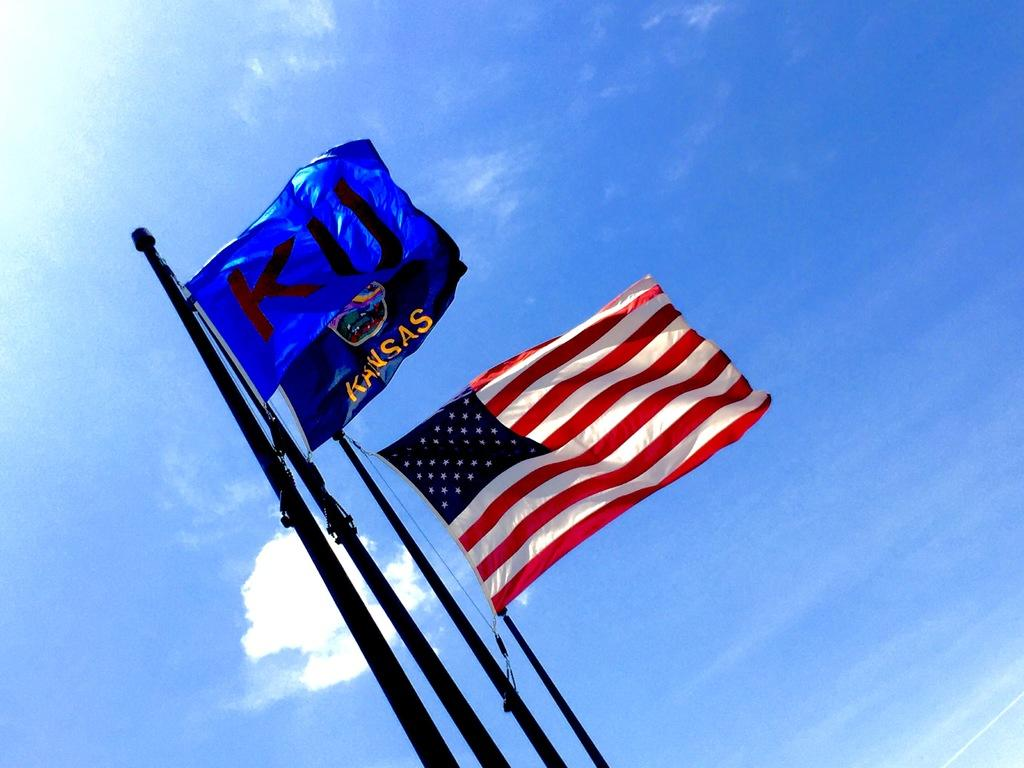What objects are on poles in the image? There are flags on poles in the image. What is visible at the top of the image? The sky is visible at the top of the image. What can be seen in the sky? There are clouds in the sky. What is written or depicted on the flags? There is text on the flags. Where is the parent bird's nest located in the image? There is no bird or nest present in the image; it only features flags on poles, the sky, and clouds. What type of nut can be seen falling from the sky in the image? There are no nuts falling from the sky in the image; it only features flags on poles, the sky, and clouds. 